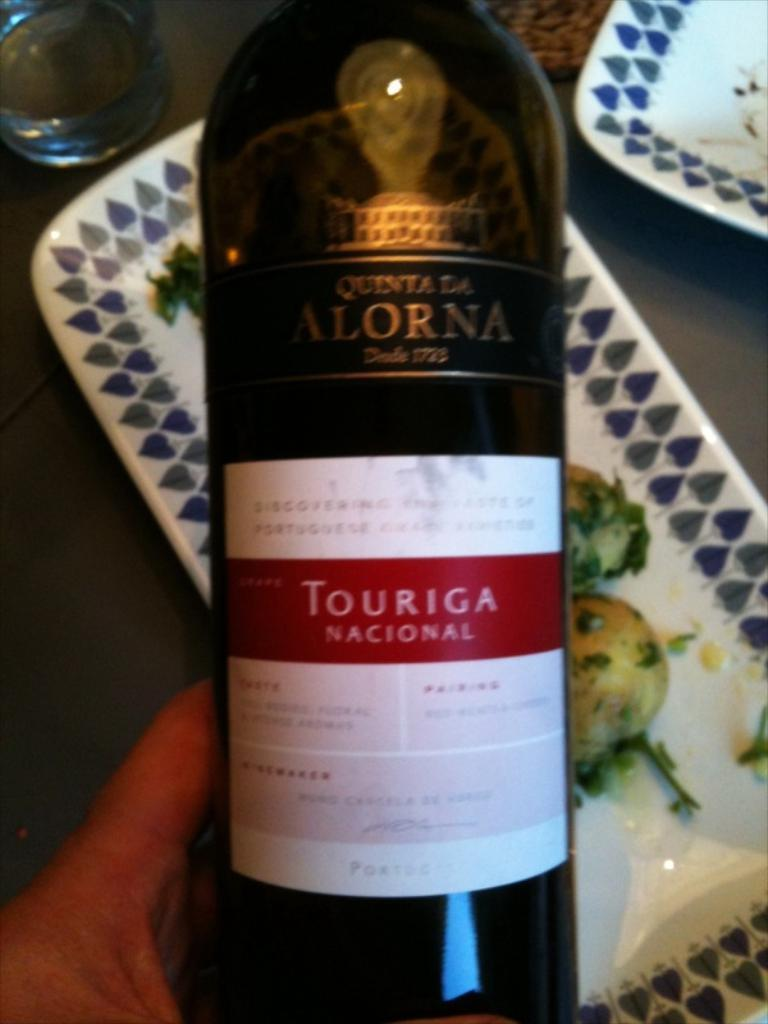<image>
Create a compact narrative representing the image presented. Wine bottle that says the word "Alorna" near the top. 